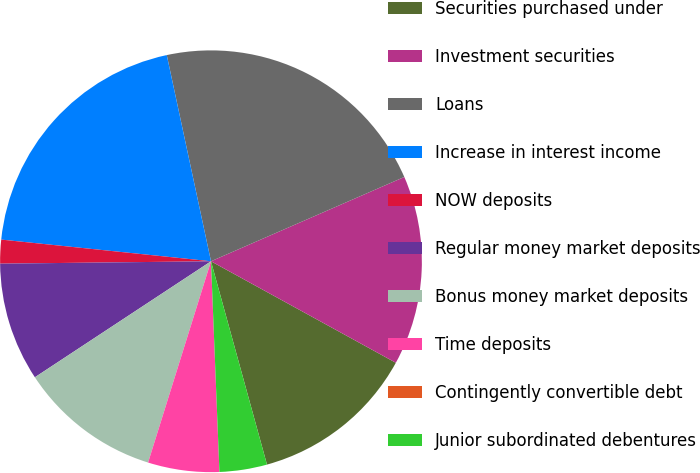Convert chart to OTSL. <chart><loc_0><loc_0><loc_500><loc_500><pie_chart><fcel>Securities purchased under<fcel>Investment securities<fcel>Loans<fcel>Increase in interest income<fcel>NOW deposits<fcel>Regular money market deposits<fcel>Bonus money market deposits<fcel>Time deposits<fcel>Contingently convertible debt<fcel>Junior subordinated debentures<nl><fcel>12.73%<fcel>14.54%<fcel>21.82%<fcel>20.0%<fcel>1.82%<fcel>9.09%<fcel>10.91%<fcel>5.46%<fcel>0.0%<fcel>3.64%<nl></chart> 